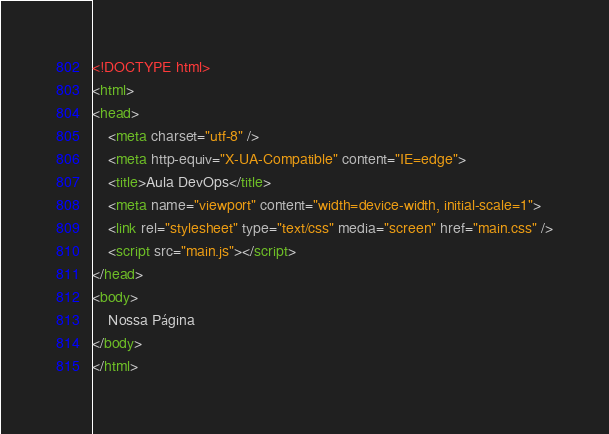Convert code to text. <code><loc_0><loc_0><loc_500><loc_500><_HTML_><!DOCTYPE html>
<html>
<head>
    <meta charset="utf-8" />
    <meta http-equiv="X-UA-Compatible" content="IE=edge">
    <title>Aula DevOps</title>
    <meta name="viewport" content="width=device-width, initial-scale=1">
    <link rel="stylesheet" type="text/css" media="screen" href="main.css" />
    <script src="main.js"></script>
</head>
<body>
    Nossa Página
</body>
</html></code> 